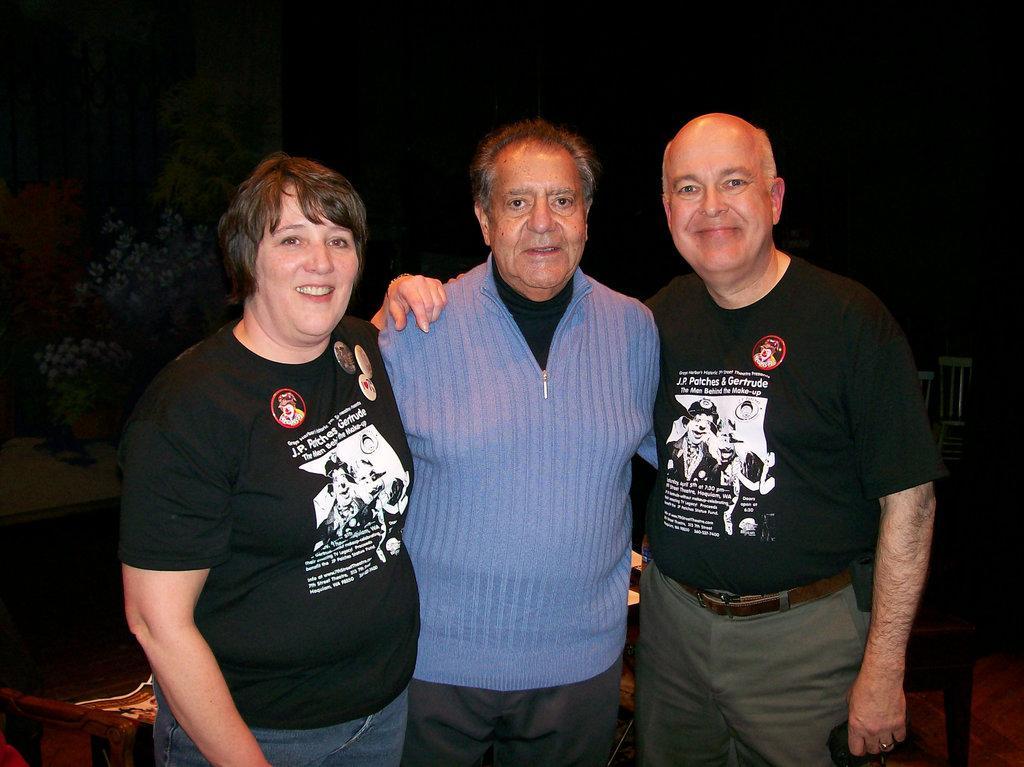Please provide a concise description of this image. In the image we can see two men and a woman standing, they are wearing clothes and they are smiling. We can even see there are chairs and the background is dark. 